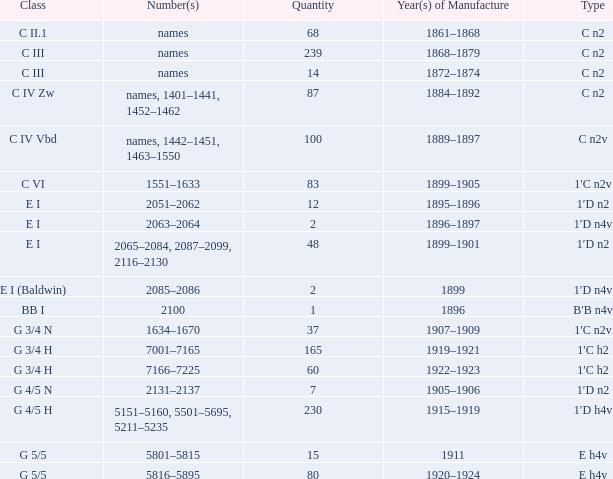Which Quantity has a Type of e h4v, and a Year(s) of Manufacture of 1920–1924? 80.0. 